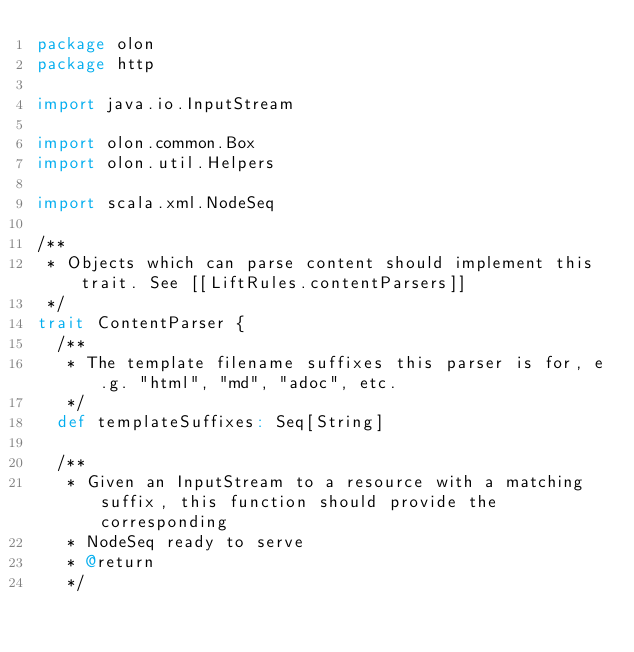<code> <loc_0><loc_0><loc_500><loc_500><_Scala_>package olon
package http

import java.io.InputStream

import olon.common.Box
import olon.util.Helpers

import scala.xml.NodeSeq

/**
 * Objects which can parse content should implement this trait. See [[LiftRules.contentParsers]]
 */
trait ContentParser {
  /**
   * The template filename suffixes this parser is for, e.g. "html", "md", "adoc", etc.
   */
  def templateSuffixes: Seq[String]

  /**
   * Given an InputStream to a resource with a matching suffix, this function should provide the corresponding
   * NodeSeq ready to serve
   * @return
   */</code> 